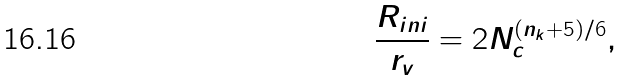Convert formula to latex. <formula><loc_0><loc_0><loc_500><loc_500>\frac { R _ { i n i } } { r _ { v } } = 2 N _ { c } ^ { ( n _ { k } + 5 ) / 6 } ,</formula> 